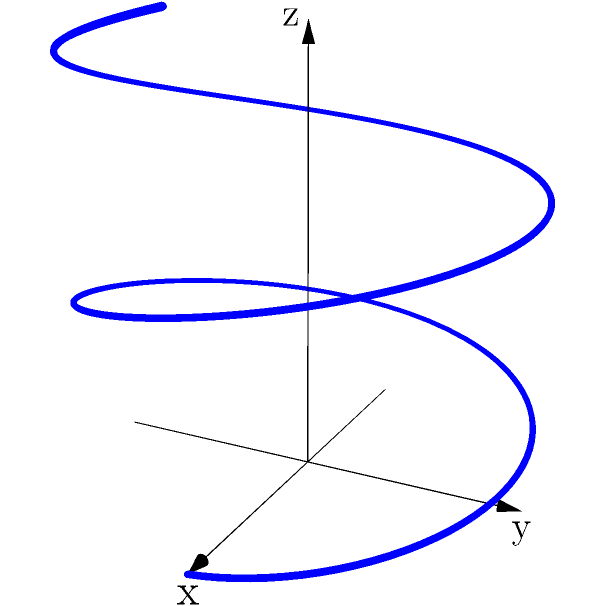You are designing a spiral staircase for a luxury treehouse. The staircase can be modeled using the parametric equations:

$$x = 2\cos(t)$$
$$y = 2\sin(t)$$
$$z = 0.5t$$

Where $t$ is the parameter representing the angle of rotation in radians. If the treehouse is 20 feet high, what is the total length of the spiral staircase from the ground to the treehouse entrance? (Round your answer to the nearest foot.) To find the length of the spiral staircase, we need to calculate the arc length of the parametric curve from $t=0$ to the value of $t$ that gives us a height of 20 feet. Let's approach this step-by-step:

1) First, we need to find the value of $t$ when $z = 20$:
   $$20 = 0.5t$$
   $$t = 40$$ radians

2) The arc length formula for a parametric curve is:
   $$L = \int_a^b \sqrt{(\frac{dx}{dt})^2 + (\frac{dy}{dt})^2 + (\frac{dz}{dt})^2} dt$$

3) Let's calculate the derivatives:
   $$\frac{dx}{dt} = -2\sin(t)$$
   $$\frac{dy}{dt} = 2\cos(t)$$
   $$\frac{dz}{dt} = 0.5$$

4) Substituting into the arc length formula:
   $$L = \int_0^{40} \sqrt{(-2\sin(t))^2 + (2\cos(t))^2 + (0.5)^2} dt$$

5) Simplify under the square root:
   $$L = \int_0^{40} \sqrt{4\sin^2(t) + 4\cos^2(t) + 0.25} dt$$
   $$L = \int_0^{40} \sqrt{4(\sin^2(t) + \cos^2(t)) + 0.25} dt$$
   $$L = \int_0^{40} \sqrt{4 + 0.25} dt$$ (since $\sin^2(t) + \cos^2(t) = 1$)
   $$L = \int_0^{40} \sqrt{4.25} dt$$
   $$L = \sqrt{4.25} \int_0^{40} dt$$

6) Evaluate the integral:
   $$L = \sqrt{4.25} [t]_0^{40}$$
   $$L = 40\sqrt{4.25} \approx 82.46$$ feet

7) Rounding to the nearest foot:
   $$L \approx 82$$ feet
Answer: 82 feet 